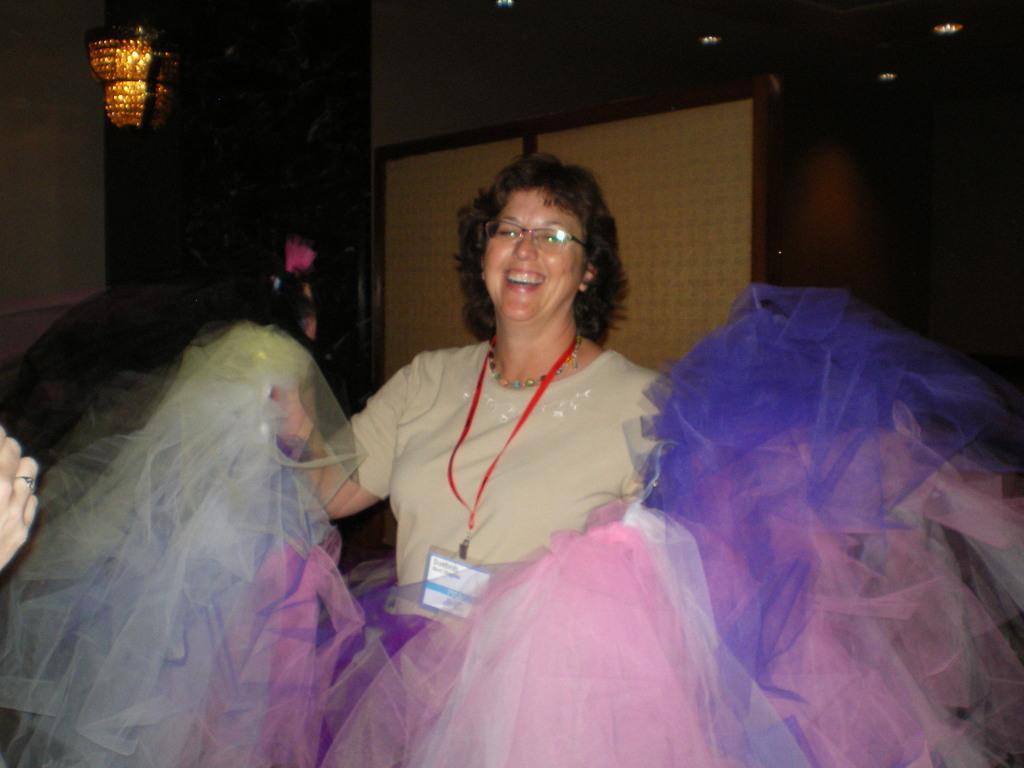How would you summarize this image in a sentence or two? In this image, we can see a person wearing clothes and spectacles. There is a light in the top left of the image. There is a hand on the left side of the image. 